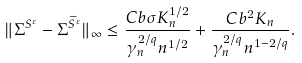Convert formula to latex. <formula><loc_0><loc_0><loc_500><loc_500>\| \Sigma ^ { S ^ { \varepsilon } } - \Sigma ^ { \widetilde { S } ^ { \varepsilon } } \| _ { \infty } \leq \frac { C b \sigma K _ { n } ^ { 1 / 2 } } { \gamma _ { n } ^ { 2 / q } n ^ { 1 / 2 } } + \frac { C b ^ { 2 } K _ { n } } { \gamma _ { n } ^ { 2 / q } n ^ { 1 - 2 / q } } .</formula> 